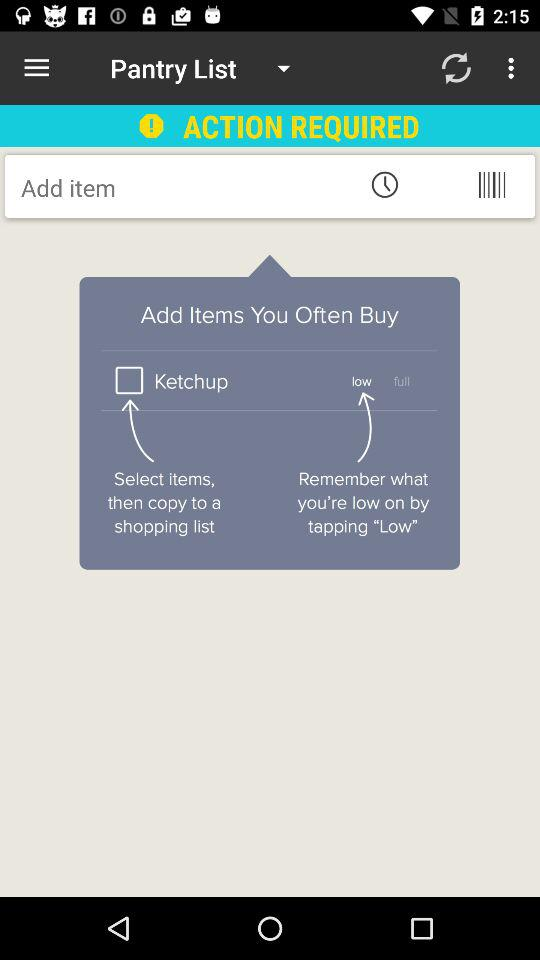What is the status of "Ketchup"? The status of "Ketchup" is "off". 